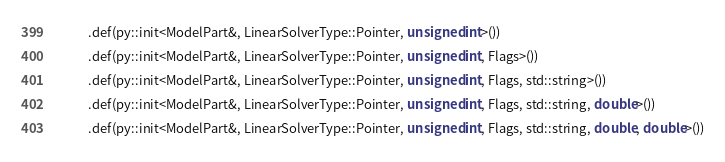Convert code to text. <code><loc_0><loc_0><loc_500><loc_500><_C++_>            .def(py::init<ModelPart&, LinearSolverType::Pointer, unsigned int>())
            .def(py::init<ModelPart&, LinearSolverType::Pointer, unsigned int, Flags>())
            .def(py::init<ModelPart&, LinearSolverType::Pointer, unsigned int, Flags, std::string>())
            .def(py::init<ModelPart&, LinearSolverType::Pointer, unsigned int, Flags, std::string, double>())
            .def(py::init<ModelPart&, LinearSolverType::Pointer, unsigned int, Flags, std::string, double, double>())</code> 